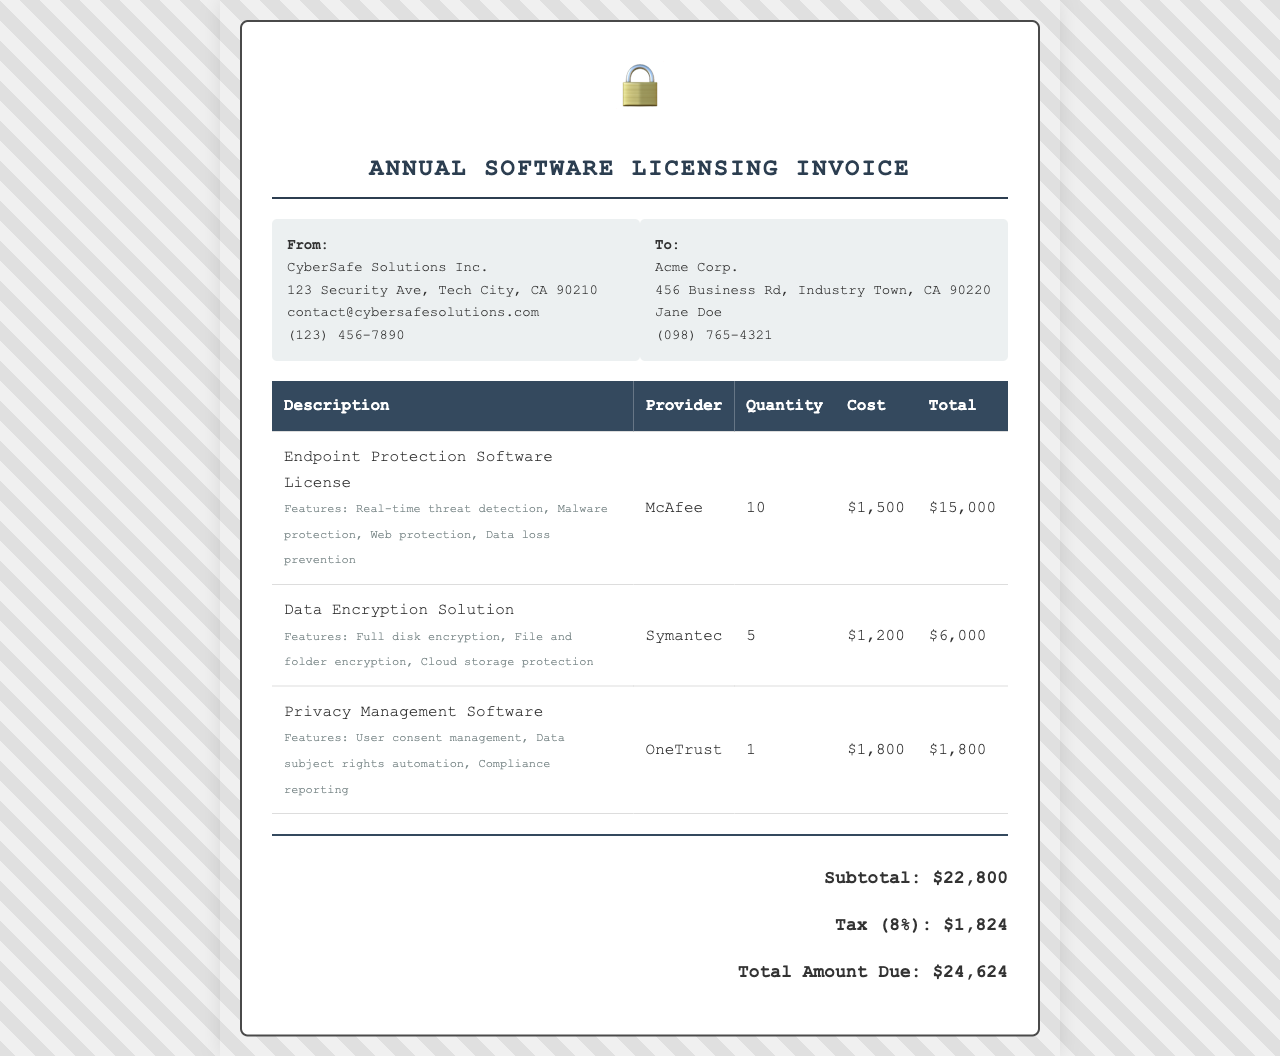What is the total amount due? The total amount due is stated in the document, which is $24,624.
Answer: $24,624 Who is the provider of the data encryption solution? The provider for the data encryption solution is listed as Symantec in the table.
Answer: Symantec How many endpoint protection software licenses were purchased? The document specifies that 10 endpoint protection software licenses were purchased.
Answer: 10 What is the cost for one Privacy Management Software license? The cost for one Privacy Management Software license is stated as $1,800 in the document.
Answer: $1,800 What features are included in the Endpoint Protection Software? The features listed for the Endpoint Protection Software are real-time threat detection, Malware protection, Web protection, and Data loss prevention.
Answer: Real-time threat detection, Malware protection, Web protection, Data loss prevention What is the subtotal before tax? The subtotal before tax is calculated from the total of all listed items, which is $22,800.
Answer: $22,800 How many licenses of the Data Encryption Solution were purchased? The document states that 5 licenses of the Data Encryption Solution were purchased.
Answer: 5 Which company issued the invoice? The invoice was issued by CyberSafe Solutions Inc. as noted at the top of the document.
Answer: CyberSafe Solutions Inc What tax rate is applied to the subtotal? The tax rate applied to the subtotal is specified as 8%.
Answer: 8% 